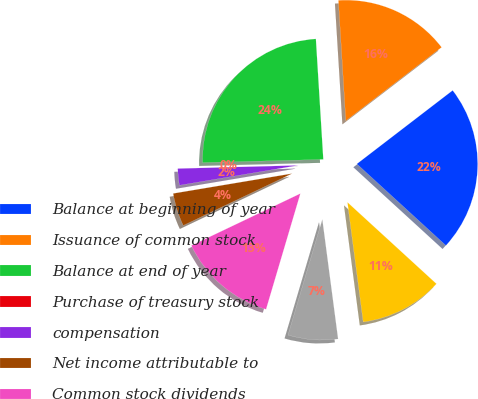Convert chart to OTSL. <chart><loc_0><loc_0><loc_500><loc_500><pie_chart><fcel>Balance at beginning of year<fcel>Issuance of common stock<fcel>Balance at end of year<fcel>Purchase of treasury stock<fcel>compensation<fcel>Net income attributable to<fcel>Common stock dividends<fcel>Other comprehensive income<fcel>Net capital activities by<nl><fcel>22.22%<fcel>15.56%<fcel>24.44%<fcel>0.0%<fcel>2.22%<fcel>4.44%<fcel>13.33%<fcel>6.67%<fcel>11.11%<nl></chart> 